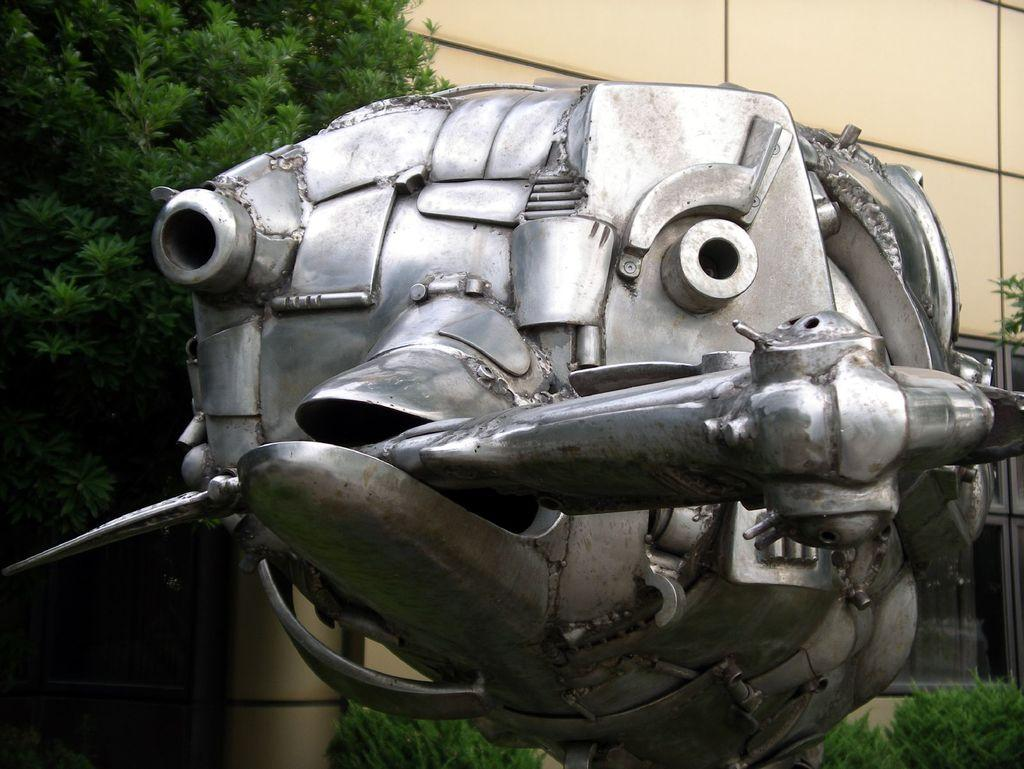What is the main subject in the middle of the image? There is a statue in the middle of the image. What can be seen in the background of the image? There are trees, plants, and a building in the background of the image. What type of rose is growing on the carriage in the image? There is no carriage or rose present in the image; it features a statue and background elements of trees, plants, and a building. 